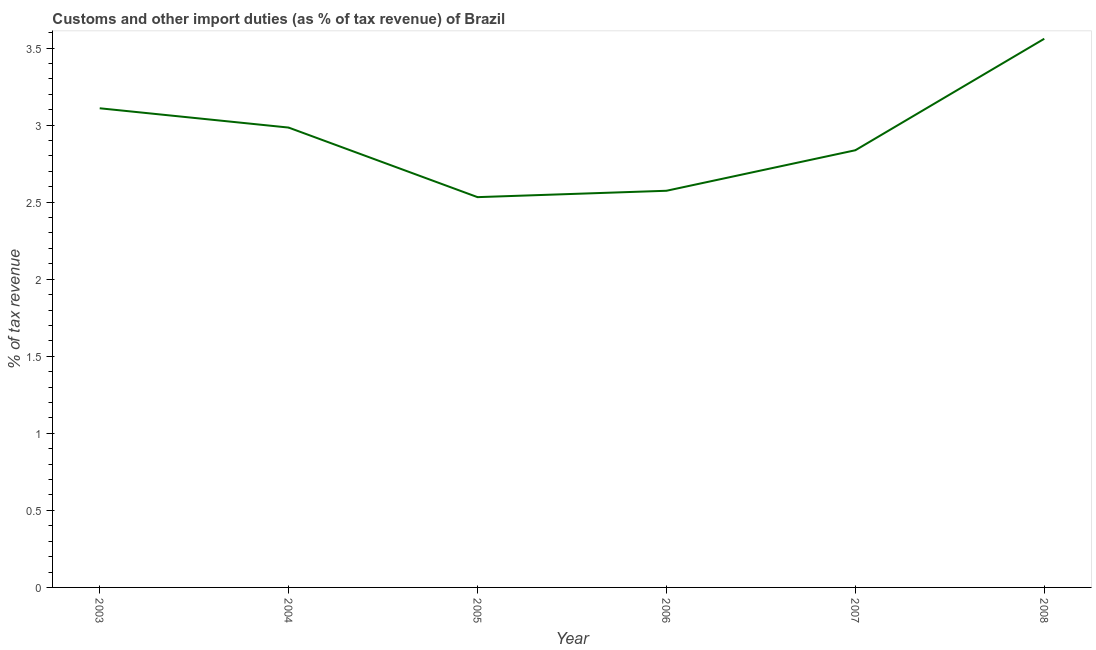What is the customs and other import duties in 2007?
Ensure brevity in your answer.  2.84. Across all years, what is the maximum customs and other import duties?
Keep it short and to the point. 3.56. Across all years, what is the minimum customs and other import duties?
Make the answer very short. 2.53. In which year was the customs and other import duties maximum?
Offer a terse response. 2008. What is the sum of the customs and other import duties?
Give a very brief answer. 17.6. What is the difference between the customs and other import duties in 2003 and 2005?
Ensure brevity in your answer.  0.58. What is the average customs and other import duties per year?
Your answer should be very brief. 2.93. What is the median customs and other import duties?
Give a very brief answer. 2.91. What is the ratio of the customs and other import duties in 2005 to that in 2007?
Offer a very short reply. 0.89. Is the customs and other import duties in 2004 less than that in 2008?
Offer a terse response. Yes. What is the difference between the highest and the second highest customs and other import duties?
Ensure brevity in your answer.  0.45. Is the sum of the customs and other import duties in 2006 and 2008 greater than the maximum customs and other import duties across all years?
Make the answer very short. Yes. What is the difference between the highest and the lowest customs and other import duties?
Your answer should be very brief. 1.03. In how many years, is the customs and other import duties greater than the average customs and other import duties taken over all years?
Provide a short and direct response. 3. Does the customs and other import duties monotonically increase over the years?
Keep it short and to the point. No. How many lines are there?
Offer a terse response. 1. What is the difference between two consecutive major ticks on the Y-axis?
Offer a very short reply. 0.5. Does the graph contain any zero values?
Provide a short and direct response. No. Does the graph contain grids?
Your response must be concise. No. What is the title of the graph?
Your answer should be compact. Customs and other import duties (as % of tax revenue) of Brazil. What is the label or title of the Y-axis?
Give a very brief answer. % of tax revenue. What is the % of tax revenue in 2003?
Provide a short and direct response. 3.11. What is the % of tax revenue in 2004?
Provide a succinct answer. 2.98. What is the % of tax revenue in 2005?
Offer a very short reply. 2.53. What is the % of tax revenue in 2006?
Offer a very short reply. 2.57. What is the % of tax revenue of 2007?
Your answer should be compact. 2.84. What is the % of tax revenue of 2008?
Ensure brevity in your answer.  3.56. What is the difference between the % of tax revenue in 2003 and 2004?
Your answer should be compact. 0.13. What is the difference between the % of tax revenue in 2003 and 2005?
Give a very brief answer. 0.58. What is the difference between the % of tax revenue in 2003 and 2006?
Offer a terse response. 0.54. What is the difference between the % of tax revenue in 2003 and 2007?
Provide a succinct answer. 0.27. What is the difference between the % of tax revenue in 2003 and 2008?
Keep it short and to the point. -0.45. What is the difference between the % of tax revenue in 2004 and 2005?
Your answer should be very brief. 0.45. What is the difference between the % of tax revenue in 2004 and 2006?
Your response must be concise. 0.41. What is the difference between the % of tax revenue in 2004 and 2007?
Ensure brevity in your answer.  0.15. What is the difference between the % of tax revenue in 2004 and 2008?
Provide a short and direct response. -0.58. What is the difference between the % of tax revenue in 2005 and 2006?
Your response must be concise. -0.04. What is the difference between the % of tax revenue in 2005 and 2007?
Your response must be concise. -0.3. What is the difference between the % of tax revenue in 2005 and 2008?
Your response must be concise. -1.03. What is the difference between the % of tax revenue in 2006 and 2007?
Provide a succinct answer. -0.26. What is the difference between the % of tax revenue in 2006 and 2008?
Offer a very short reply. -0.99. What is the difference between the % of tax revenue in 2007 and 2008?
Provide a short and direct response. -0.72. What is the ratio of the % of tax revenue in 2003 to that in 2004?
Provide a succinct answer. 1.04. What is the ratio of the % of tax revenue in 2003 to that in 2005?
Your answer should be compact. 1.23. What is the ratio of the % of tax revenue in 2003 to that in 2006?
Provide a short and direct response. 1.21. What is the ratio of the % of tax revenue in 2003 to that in 2007?
Your answer should be very brief. 1.1. What is the ratio of the % of tax revenue in 2003 to that in 2008?
Your response must be concise. 0.87. What is the ratio of the % of tax revenue in 2004 to that in 2005?
Offer a very short reply. 1.18. What is the ratio of the % of tax revenue in 2004 to that in 2006?
Give a very brief answer. 1.16. What is the ratio of the % of tax revenue in 2004 to that in 2007?
Make the answer very short. 1.05. What is the ratio of the % of tax revenue in 2004 to that in 2008?
Give a very brief answer. 0.84. What is the ratio of the % of tax revenue in 2005 to that in 2006?
Your answer should be compact. 0.98. What is the ratio of the % of tax revenue in 2005 to that in 2007?
Offer a very short reply. 0.89. What is the ratio of the % of tax revenue in 2005 to that in 2008?
Provide a short and direct response. 0.71. What is the ratio of the % of tax revenue in 2006 to that in 2007?
Keep it short and to the point. 0.91. What is the ratio of the % of tax revenue in 2006 to that in 2008?
Provide a succinct answer. 0.72. What is the ratio of the % of tax revenue in 2007 to that in 2008?
Your answer should be very brief. 0.8. 